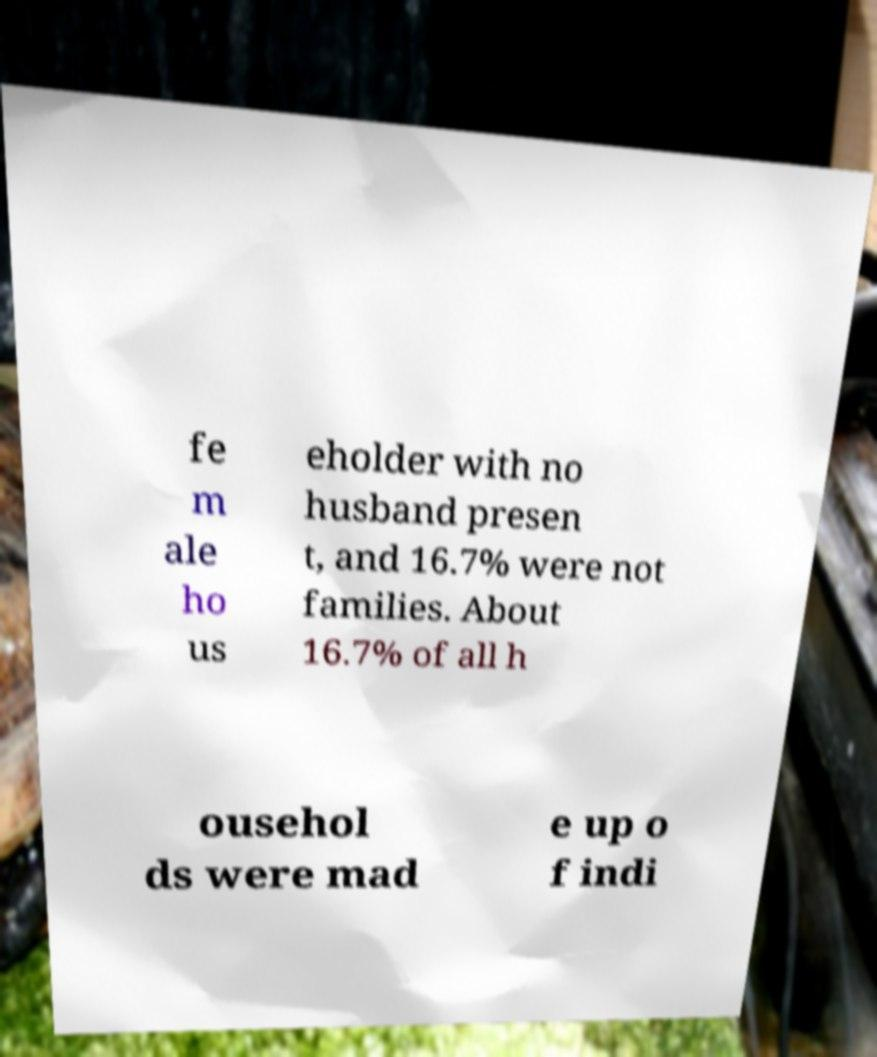Can you read and provide the text displayed in the image?This photo seems to have some interesting text. Can you extract and type it out for me? fe m ale ho us eholder with no husband presen t, and 16.7% were not families. About 16.7% of all h ousehol ds were mad e up o f indi 